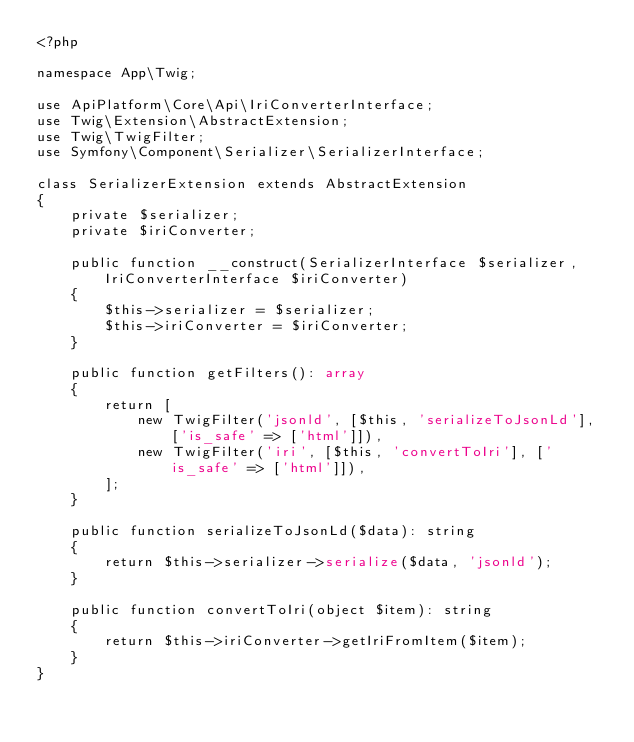Convert code to text. <code><loc_0><loc_0><loc_500><loc_500><_PHP_><?php

namespace App\Twig;

use ApiPlatform\Core\Api\IriConverterInterface;
use Twig\Extension\AbstractExtension;
use Twig\TwigFilter;
use Symfony\Component\Serializer\SerializerInterface;

class SerializerExtension extends AbstractExtension
{
    private $serializer;
    private $iriConverter;

    public function __construct(SerializerInterface $serializer, IriConverterInterface $iriConverter)
    {
        $this->serializer = $serializer;
        $this->iriConverter = $iriConverter;
    }

    public function getFilters(): array
    {
        return [
            new TwigFilter('jsonld', [$this, 'serializeToJsonLd'], ['is_safe' => ['html']]),
            new TwigFilter('iri', [$this, 'convertToIri'], ['is_safe' => ['html']]),
        ];
    }

    public function serializeToJsonLd($data): string
    {
        return $this->serializer->serialize($data, 'jsonld');
    }

    public function convertToIri(object $item): string
    {
        return $this->iriConverter->getIriFromItem($item);
    }
}
</code> 